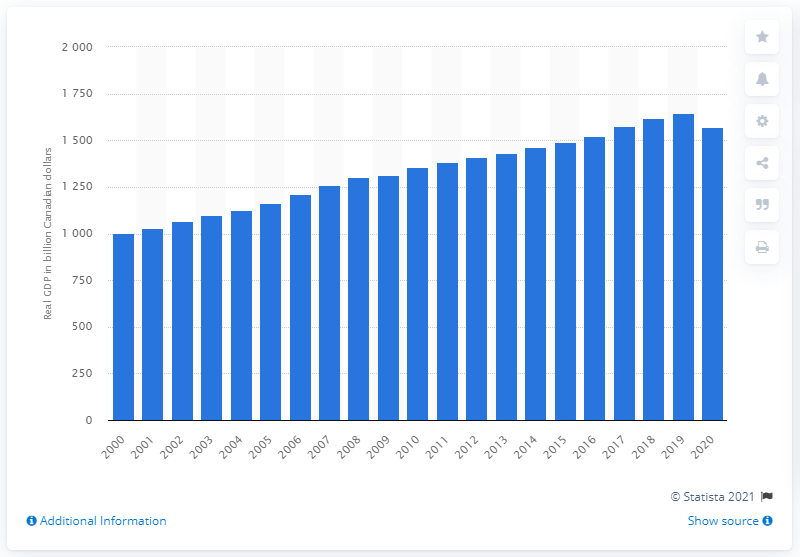Identify some key points in this picture. In 2012, the real GDP of Canada was valued at constant prices, equal to 1573.4... 